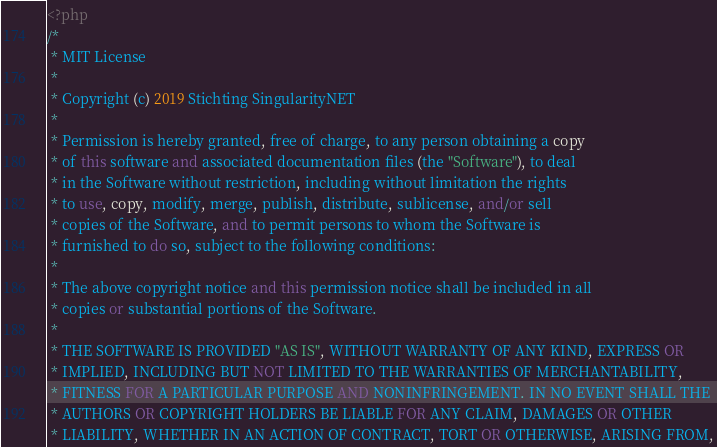Convert code to text. <code><loc_0><loc_0><loc_500><loc_500><_PHP_><?php
/*
 * MIT License
 * 
 * Copyright (c) 2019 Stichting SingularityNET
 *
 * Permission is hereby granted, free of charge, to any person obtaining a copy
 * of this software and associated documentation files (the "Software"), to deal
 * in the Software without restriction, including without limitation the rights
 * to use, copy, modify, merge, publish, distribute, sublicense, and/or sell
 * copies of the Software, and to permit persons to whom the Software is
 * furnished to do so, subject to the following conditions:
 *
 * The above copyright notice and this permission notice shall be included in all
 * copies or substantial portions of the Software.
 *
 * THE SOFTWARE IS PROVIDED "AS IS", WITHOUT WARRANTY OF ANY KIND, EXPRESS OR
 * IMPLIED, INCLUDING BUT NOT LIMITED TO THE WARRANTIES OF MERCHANTABILITY,
 * FITNESS FOR A PARTICULAR PURPOSE AND NONINFRINGEMENT. IN NO EVENT SHALL THE
 * AUTHORS OR COPYRIGHT HOLDERS BE LIABLE FOR ANY CLAIM, DAMAGES OR OTHER
 * LIABILITY, WHETHER IN AN ACTION OF CONTRACT, TORT OR OTHERWISE, ARISING FROM,</code> 